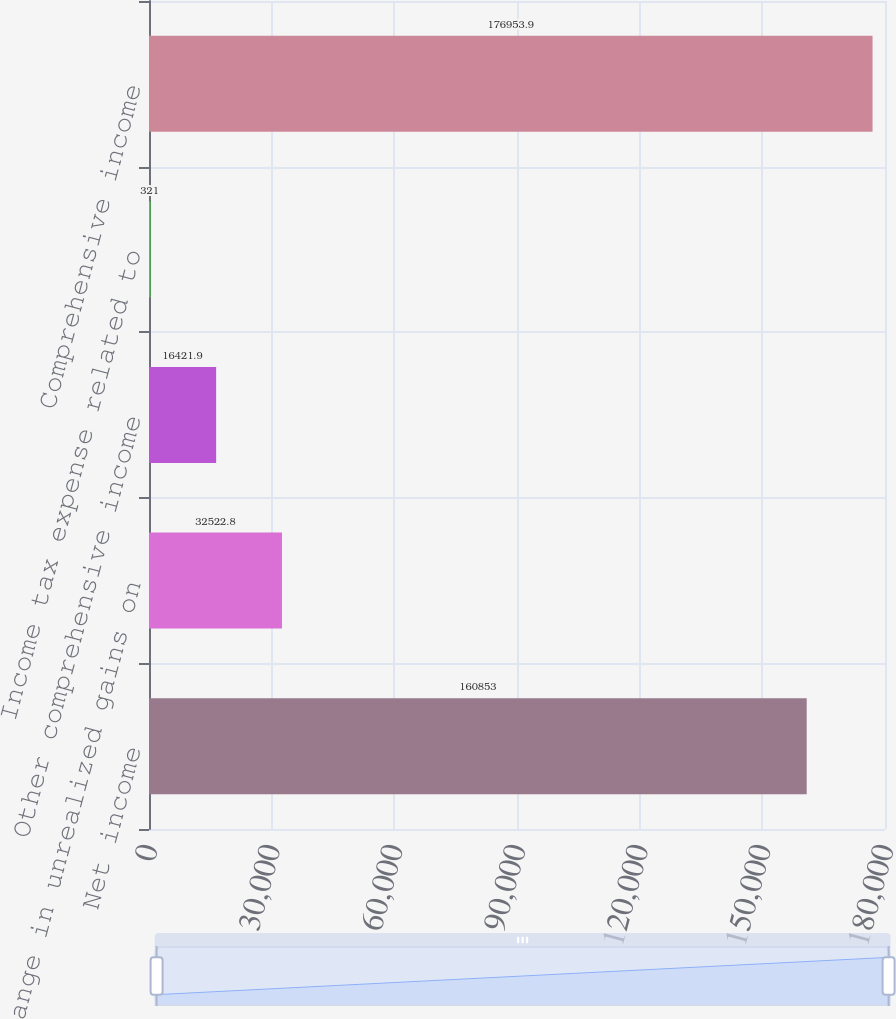Convert chart to OTSL. <chart><loc_0><loc_0><loc_500><loc_500><bar_chart><fcel>Net income<fcel>Change in unrealized gains on<fcel>Other comprehensive income<fcel>Income tax expense related to<fcel>Comprehensive income<nl><fcel>160853<fcel>32522.8<fcel>16421.9<fcel>321<fcel>176954<nl></chart> 